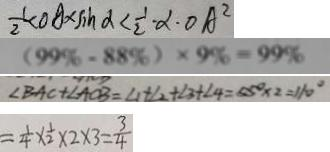Convert formula to latex. <formula><loc_0><loc_0><loc_500><loc_500>\frac { 1 } { 2 } < O A \times \sin \alpha < \frac { 1 } { 2 } \cdot \alpha \cdot O A ^ { 2 } 
 ( 9 9 \% - 8 8 \% ) \times 9 \% = 9 9 \% 
 \angle B A C + \angle A C B = \angle 1 + \angle 2 + \angle 3 + \angle 4 = 5 5 ^ { \circ } \times 2 = 1 1 0 ^ { \circ } 
 = \frac { 1 } { 4 } \times \frac { 1 } { 2 } \times 2 \times 3 = \frac { 3 } { 4 }</formula> 